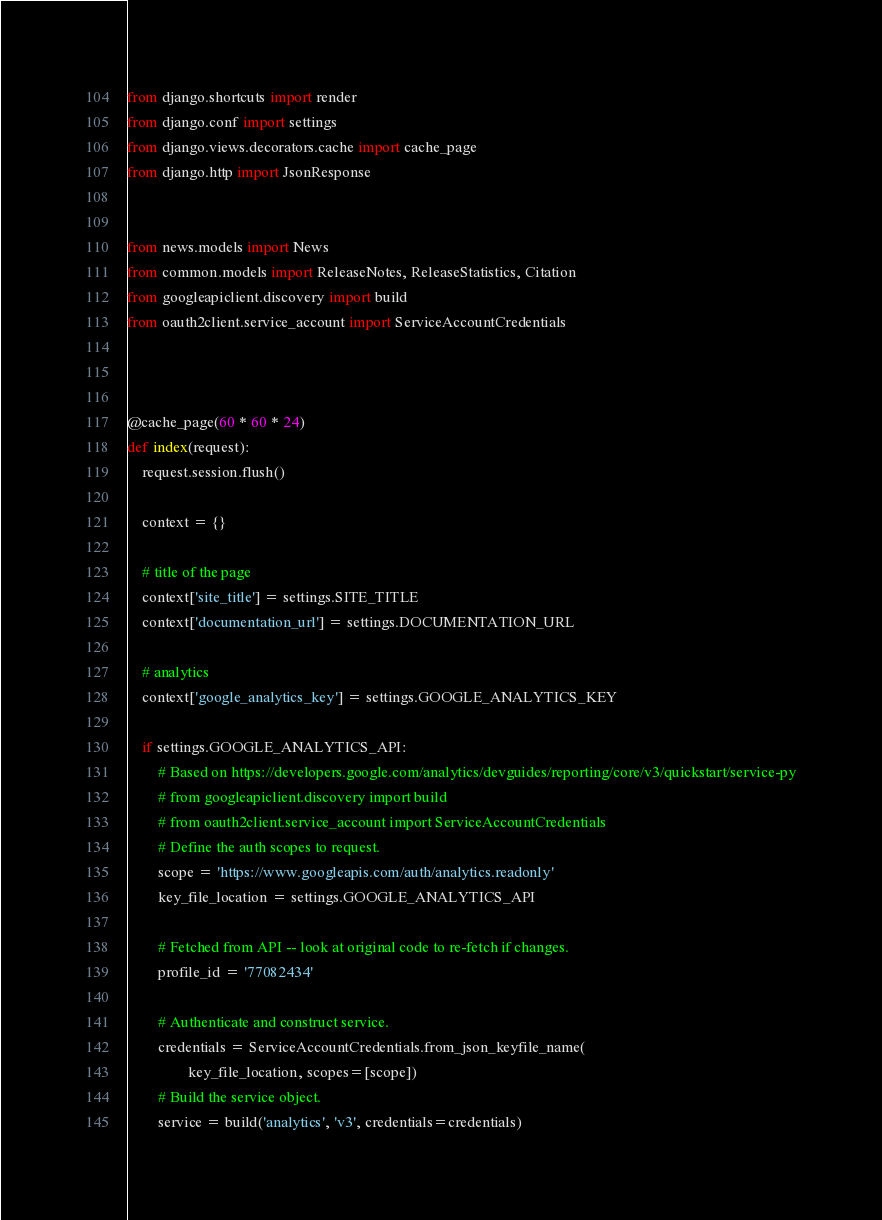<code> <loc_0><loc_0><loc_500><loc_500><_Python_>from django.shortcuts import render
from django.conf import settings
from django.views.decorators.cache import cache_page
from django.http import JsonResponse


from news.models import News
from common.models import ReleaseNotes, ReleaseStatistics, Citation
from googleapiclient.discovery import build
from oauth2client.service_account import ServiceAccountCredentials



@cache_page(60 * 60 * 24)
def index(request):
    request.session.flush()

    context = {}

    # title of the page
    context['site_title'] = settings.SITE_TITLE
    context['documentation_url'] = settings.DOCUMENTATION_URL

    # analytics
    context['google_analytics_key'] = settings.GOOGLE_ANALYTICS_KEY

    if settings.GOOGLE_ANALYTICS_API:
        # Based on https://developers.google.com/analytics/devguides/reporting/core/v3/quickstart/service-py
        # from googleapiclient.discovery import build
        # from oauth2client.service_account import ServiceAccountCredentials
        # Define the auth scopes to request.
        scope = 'https://www.googleapis.com/auth/analytics.readonly'
        key_file_location = settings.GOOGLE_ANALYTICS_API

        # Fetched from API -- look at original code to re-fetch if changes.
        profile_id = '77082434' 

        # Authenticate and construct service.
        credentials = ServiceAccountCredentials.from_json_keyfile_name(
                key_file_location, scopes=[scope])
        # Build the service object.
        service = build('analytics', 'v3', credentials=credentials)
</code> 